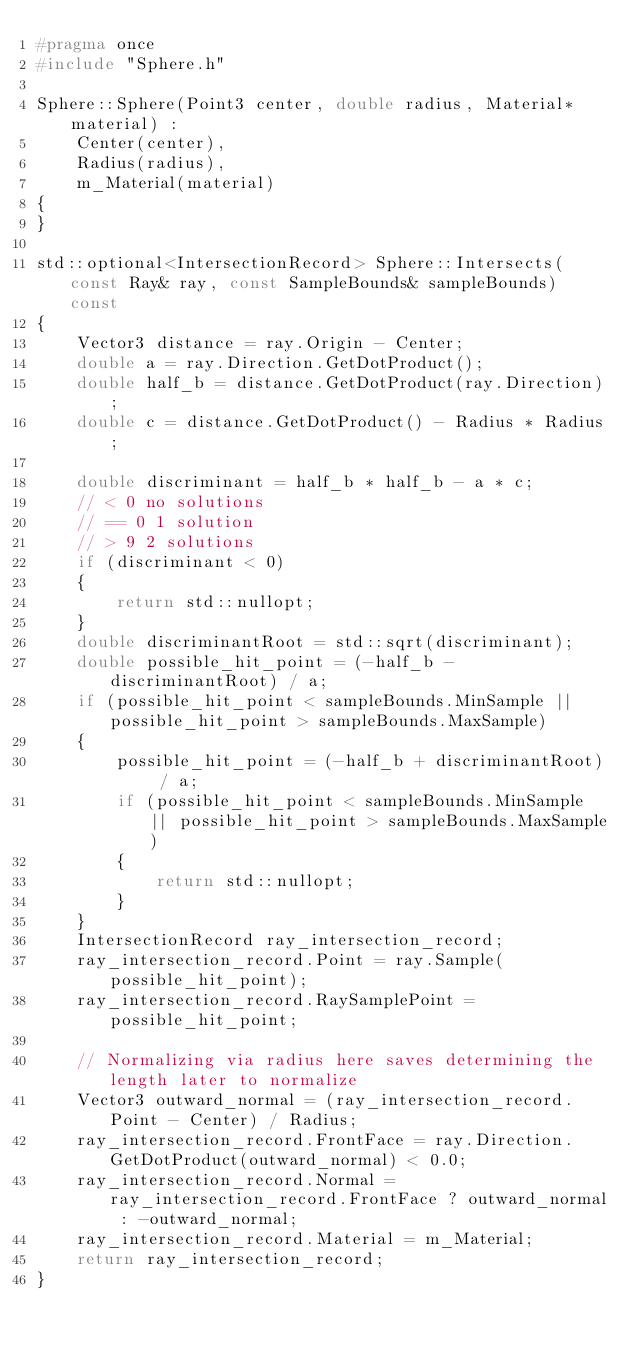<code> <loc_0><loc_0><loc_500><loc_500><_C++_>#pragma once
#include "Sphere.h"

Sphere::Sphere(Point3 center, double radius, Material* material) :
	Center(center),
	Radius(radius),
	m_Material(material)
{
}

std::optional<IntersectionRecord> Sphere::Intersects(const Ray& ray, const SampleBounds& sampleBounds) const
{
	Vector3 distance = ray.Origin - Center;
	double a = ray.Direction.GetDotProduct();
	double half_b = distance.GetDotProduct(ray.Direction);
	double c = distance.GetDotProduct() - Radius * Radius;

	double discriminant = half_b * half_b - a * c;
	// < 0 no solutions
	// == 0 1 solution
	// > 9 2 solutions
	if (discriminant < 0)
	{
		return std::nullopt;
	}
	double discriminantRoot = std::sqrt(discriminant);
	double possible_hit_point = (-half_b - discriminantRoot) / a;
	if (possible_hit_point < sampleBounds.MinSample || possible_hit_point > sampleBounds.MaxSample)
	{
		possible_hit_point = (-half_b + discriminantRoot) / a;
		if (possible_hit_point < sampleBounds.MinSample || possible_hit_point > sampleBounds.MaxSample)
		{
			return std::nullopt;
		}
	}
	IntersectionRecord ray_intersection_record;
	ray_intersection_record.Point = ray.Sample(possible_hit_point);
	ray_intersection_record.RaySamplePoint = possible_hit_point;

	// Normalizing via radius here saves determining the length later to normalize
	Vector3 outward_normal = (ray_intersection_record.Point - Center) / Radius;
	ray_intersection_record.FrontFace = ray.Direction.GetDotProduct(outward_normal) < 0.0;
	ray_intersection_record.Normal = ray_intersection_record.FrontFace ? outward_normal : -outward_normal;
	ray_intersection_record.Material = m_Material;
	return ray_intersection_record;
}
</code> 